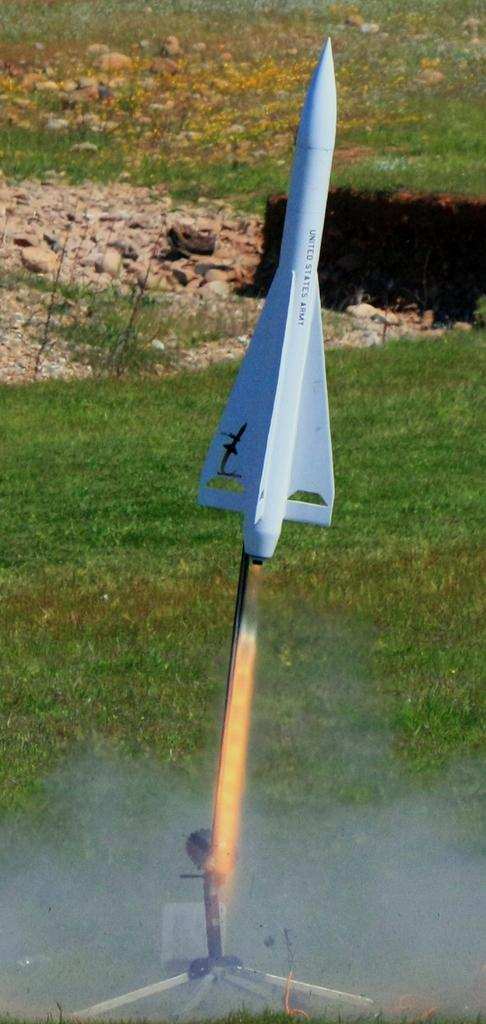What is the main subject of the image? There is a white color rocket in the image. What can be seen in the background of the image? There are rocks in the background of the image. What type of vegetation is visible in the image? There is grass visible in the image. What is present on the ground in the image? There are objects on the ground in the image. How many turkeys can be seen in the image? There are no turkeys present in the image. What type of harbor can be seen in the image? There is no harbor present in the image. 